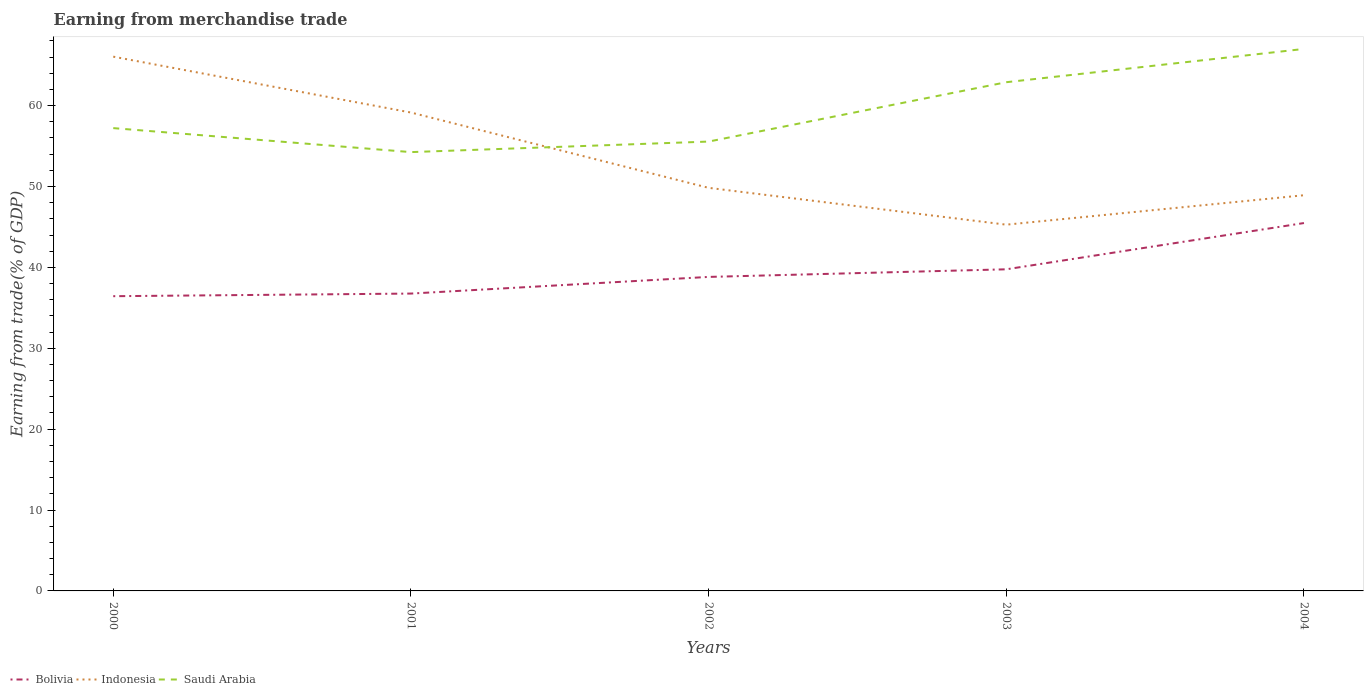How many different coloured lines are there?
Give a very brief answer. 3. Across all years, what is the maximum earnings from trade in Indonesia?
Provide a short and direct response. 45.28. In which year was the earnings from trade in Bolivia maximum?
Offer a very short reply. 2000. What is the total earnings from trade in Bolivia in the graph?
Keep it short and to the point. -0.32. What is the difference between the highest and the second highest earnings from trade in Indonesia?
Ensure brevity in your answer.  20.77. Is the earnings from trade in Bolivia strictly greater than the earnings from trade in Indonesia over the years?
Provide a succinct answer. Yes. How many lines are there?
Your response must be concise. 3. Are the values on the major ticks of Y-axis written in scientific E-notation?
Offer a terse response. No. Where does the legend appear in the graph?
Make the answer very short. Bottom left. What is the title of the graph?
Your response must be concise. Earning from merchandise trade. Does "Sub-Saharan Africa (developing only)" appear as one of the legend labels in the graph?
Keep it short and to the point. No. What is the label or title of the X-axis?
Your answer should be very brief. Years. What is the label or title of the Y-axis?
Provide a short and direct response. Earning from trade(% of GDP). What is the Earning from trade(% of GDP) in Bolivia in 2000?
Give a very brief answer. 36.44. What is the Earning from trade(% of GDP) in Indonesia in 2000?
Your answer should be compact. 66.05. What is the Earning from trade(% of GDP) of Saudi Arabia in 2000?
Provide a short and direct response. 57.22. What is the Earning from trade(% of GDP) of Bolivia in 2001?
Ensure brevity in your answer.  36.76. What is the Earning from trade(% of GDP) of Indonesia in 2001?
Your response must be concise. 59.14. What is the Earning from trade(% of GDP) of Saudi Arabia in 2001?
Give a very brief answer. 54.25. What is the Earning from trade(% of GDP) in Bolivia in 2002?
Offer a very short reply. 38.82. What is the Earning from trade(% of GDP) of Indonesia in 2002?
Your response must be concise. 49.83. What is the Earning from trade(% of GDP) of Saudi Arabia in 2002?
Ensure brevity in your answer.  55.55. What is the Earning from trade(% of GDP) of Bolivia in 2003?
Your answer should be compact. 39.76. What is the Earning from trade(% of GDP) of Indonesia in 2003?
Give a very brief answer. 45.28. What is the Earning from trade(% of GDP) of Saudi Arabia in 2003?
Offer a terse response. 62.89. What is the Earning from trade(% of GDP) of Bolivia in 2004?
Make the answer very short. 45.48. What is the Earning from trade(% of GDP) of Indonesia in 2004?
Offer a terse response. 48.92. What is the Earning from trade(% of GDP) in Saudi Arabia in 2004?
Keep it short and to the point. 67.01. Across all years, what is the maximum Earning from trade(% of GDP) of Bolivia?
Your response must be concise. 45.48. Across all years, what is the maximum Earning from trade(% of GDP) in Indonesia?
Your answer should be very brief. 66.05. Across all years, what is the maximum Earning from trade(% of GDP) in Saudi Arabia?
Provide a short and direct response. 67.01. Across all years, what is the minimum Earning from trade(% of GDP) of Bolivia?
Give a very brief answer. 36.44. Across all years, what is the minimum Earning from trade(% of GDP) in Indonesia?
Your response must be concise. 45.28. Across all years, what is the minimum Earning from trade(% of GDP) of Saudi Arabia?
Provide a short and direct response. 54.25. What is the total Earning from trade(% of GDP) of Bolivia in the graph?
Your answer should be very brief. 197.26. What is the total Earning from trade(% of GDP) in Indonesia in the graph?
Give a very brief answer. 269.23. What is the total Earning from trade(% of GDP) of Saudi Arabia in the graph?
Provide a succinct answer. 296.92. What is the difference between the Earning from trade(% of GDP) of Bolivia in 2000 and that in 2001?
Your answer should be very brief. -0.32. What is the difference between the Earning from trade(% of GDP) of Indonesia in 2000 and that in 2001?
Make the answer very short. 6.91. What is the difference between the Earning from trade(% of GDP) of Saudi Arabia in 2000 and that in 2001?
Offer a terse response. 2.97. What is the difference between the Earning from trade(% of GDP) in Bolivia in 2000 and that in 2002?
Make the answer very short. -2.38. What is the difference between the Earning from trade(% of GDP) of Indonesia in 2000 and that in 2002?
Provide a short and direct response. 16.22. What is the difference between the Earning from trade(% of GDP) in Saudi Arabia in 2000 and that in 2002?
Give a very brief answer. 1.66. What is the difference between the Earning from trade(% of GDP) in Bolivia in 2000 and that in 2003?
Your answer should be compact. -3.32. What is the difference between the Earning from trade(% of GDP) in Indonesia in 2000 and that in 2003?
Your answer should be compact. 20.77. What is the difference between the Earning from trade(% of GDP) of Saudi Arabia in 2000 and that in 2003?
Ensure brevity in your answer.  -5.68. What is the difference between the Earning from trade(% of GDP) of Bolivia in 2000 and that in 2004?
Ensure brevity in your answer.  -9.04. What is the difference between the Earning from trade(% of GDP) of Indonesia in 2000 and that in 2004?
Your answer should be very brief. 17.13. What is the difference between the Earning from trade(% of GDP) of Saudi Arabia in 2000 and that in 2004?
Make the answer very short. -9.79. What is the difference between the Earning from trade(% of GDP) of Bolivia in 2001 and that in 2002?
Your response must be concise. -2.06. What is the difference between the Earning from trade(% of GDP) of Indonesia in 2001 and that in 2002?
Offer a terse response. 9.31. What is the difference between the Earning from trade(% of GDP) in Saudi Arabia in 2001 and that in 2002?
Keep it short and to the point. -1.3. What is the difference between the Earning from trade(% of GDP) in Bolivia in 2001 and that in 2003?
Keep it short and to the point. -3. What is the difference between the Earning from trade(% of GDP) of Indonesia in 2001 and that in 2003?
Offer a terse response. 13.86. What is the difference between the Earning from trade(% of GDP) of Saudi Arabia in 2001 and that in 2003?
Make the answer very short. -8.64. What is the difference between the Earning from trade(% of GDP) in Bolivia in 2001 and that in 2004?
Give a very brief answer. -8.72. What is the difference between the Earning from trade(% of GDP) of Indonesia in 2001 and that in 2004?
Your answer should be compact. 10.22. What is the difference between the Earning from trade(% of GDP) in Saudi Arabia in 2001 and that in 2004?
Your answer should be compact. -12.75. What is the difference between the Earning from trade(% of GDP) of Bolivia in 2002 and that in 2003?
Your answer should be compact. -0.94. What is the difference between the Earning from trade(% of GDP) in Indonesia in 2002 and that in 2003?
Your response must be concise. 4.55. What is the difference between the Earning from trade(% of GDP) in Saudi Arabia in 2002 and that in 2003?
Your answer should be very brief. -7.34. What is the difference between the Earning from trade(% of GDP) in Bolivia in 2002 and that in 2004?
Provide a succinct answer. -6.66. What is the difference between the Earning from trade(% of GDP) of Indonesia in 2002 and that in 2004?
Your answer should be compact. 0.91. What is the difference between the Earning from trade(% of GDP) of Saudi Arabia in 2002 and that in 2004?
Your response must be concise. -11.45. What is the difference between the Earning from trade(% of GDP) of Bolivia in 2003 and that in 2004?
Your response must be concise. -5.72. What is the difference between the Earning from trade(% of GDP) of Indonesia in 2003 and that in 2004?
Offer a terse response. -3.64. What is the difference between the Earning from trade(% of GDP) of Saudi Arabia in 2003 and that in 2004?
Offer a very short reply. -4.11. What is the difference between the Earning from trade(% of GDP) in Bolivia in 2000 and the Earning from trade(% of GDP) in Indonesia in 2001?
Your answer should be very brief. -22.71. What is the difference between the Earning from trade(% of GDP) in Bolivia in 2000 and the Earning from trade(% of GDP) in Saudi Arabia in 2001?
Your answer should be compact. -17.81. What is the difference between the Earning from trade(% of GDP) of Indonesia in 2000 and the Earning from trade(% of GDP) of Saudi Arabia in 2001?
Provide a short and direct response. 11.8. What is the difference between the Earning from trade(% of GDP) of Bolivia in 2000 and the Earning from trade(% of GDP) of Indonesia in 2002?
Your answer should be very brief. -13.4. What is the difference between the Earning from trade(% of GDP) in Bolivia in 2000 and the Earning from trade(% of GDP) in Saudi Arabia in 2002?
Ensure brevity in your answer.  -19.12. What is the difference between the Earning from trade(% of GDP) of Indonesia in 2000 and the Earning from trade(% of GDP) of Saudi Arabia in 2002?
Give a very brief answer. 10.5. What is the difference between the Earning from trade(% of GDP) of Bolivia in 2000 and the Earning from trade(% of GDP) of Indonesia in 2003?
Give a very brief answer. -8.84. What is the difference between the Earning from trade(% of GDP) of Bolivia in 2000 and the Earning from trade(% of GDP) of Saudi Arabia in 2003?
Your response must be concise. -26.45. What is the difference between the Earning from trade(% of GDP) of Indonesia in 2000 and the Earning from trade(% of GDP) of Saudi Arabia in 2003?
Your response must be concise. 3.16. What is the difference between the Earning from trade(% of GDP) in Bolivia in 2000 and the Earning from trade(% of GDP) in Indonesia in 2004?
Ensure brevity in your answer.  -12.48. What is the difference between the Earning from trade(% of GDP) of Bolivia in 2000 and the Earning from trade(% of GDP) of Saudi Arabia in 2004?
Offer a very short reply. -30.57. What is the difference between the Earning from trade(% of GDP) of Indonesia in 2000 and the Earning from trade(% of GDP) of Saudi Arabia in 2004?
Your answer should be very brief. -0.95. What is the difference between the Earning from trade(% of GDP) in Bolivia in 2001 and the Earning from trade(% of GDP) in Indonesia in 2002?
Your answer should be compact. -13.07. What is the difference between the Earning from trade(% of GDP) in Bolivia in 2001 and the Earning from trade(% of GDP) in Saudi Arabia in 2002?
Ensure brevity in your answer.  -18.79. What is the difference between the Earning from trade(% of GDP) in Indonesia in 2001 and the Earning from trade(% of GDP) in Saudi Arabia in 2002?
Make the answer very short. 3.59. What is the difference between the Earning from trade(% of GDP) in Bolivia in 2001 and the Earning from trade(% of GDP) in Indonesia in 2003?
Provide a short and direct response. -8.52. What is the difference between the Earning from trade(% of GDP) of Bolivia in 2001 and the Earning from trade(% of GDP) of Saudi Arabia in 2003?
Provide a short and direct response. -26.13. What is the difference between the Earning from trade(% of GDP) in Indonesia in 2001 and the Earning from trade(% of GDP) in Saudi Arabia in 2003?
Provide a succinct answer. -3.75. What is the difference between the Earning from trade(% of GDP) in Bolivia in 2001 and the Earning from trade(% of GDP) in Indonesia in 2004?
Make the answer very short. -12.16. What is the difference between the Earning from trade(% of GDP) in Bolivia in 2001 and the Earning from trade(% of GDP) in Saudi Arabia in 2004?
Keep it short and to the point. -30.24. What is the difference between the Earning from trade(% of GDP) of Indonesia in 2001 and the Earning from trade(% of GDP) of Saudi Arabia in 2004?
Provide a succinct answer. -7.86. What is the difference between the Earning from trade(% of GDP) in Bolivia in 2002 and the Earning from trade(% of GDP) in Indonesia in 2003?
Offer a terse response. -6.46. What is the difference between the Earning from trade(% of GDP) of Bolivia in 2002 and the Earning from trade(% of GDP) of Saudi Arabia in 2003?
Keep it short and to the point. -24.07. What is the difference between the Earning from trade(% of GDP) of Indonesia in 2002 and the Earning from trade(% of GDP) of Saudi Arabia in 2003?
Offer a very short reply. -13.06. What is the difference between the Earning from trade(% of GDP) in Bolivia in 2002 and the Earning from trade(% of GDP) in Indonesia in 2004?
Offer a very short reply. -10.1. What is the difference between the Earning from trade(% of GDP) of Bolivia in 2002 and the Earning from trade(% of GDP) of Saudi Arabia in 2004?
Make the answer very short. -28.18. What is the difference between the Earning from trade(% of GDP) of Indonesia in 2002 and the Earning from trade(% of GDP) of Saudi Arabia in 2004?
Offer a terse response. -17.17. What is the difference between the Earning from trade(% of GDP) in Bolivia in 2003 and the Earning from trade(% of GDP) in Indonesia in 2004?
Your response must be concise. -9.16. What is the difference between the Earning from trade(% of GDP) of Bolivia in 2003 and the Earning from trade(% of GDP) of Saudi Arabia in 2004?
Your answer should be very brief. -27.24. What is the difference between the Earning from trade(% of GDP) of Indonesia in 2003 and the Earning from trade(% of GDP) of Saudi Arabia in 2004?
Make the answer very short. -21.73. What is the average Earning from trade(% of GDP) in Bolivia per year?
Offer a terse response. 39.45. What is the average Earning from trade(% of GDP) in Indonesia per year?
Your response must be concise. 53.85. What is the average Earning from trade(% of GDP) in Saudi Arabia per year?
Ensure brevity in your answer.  59.38. In the year 2000, what is the difference between the Earning from trade(% of GDP) of Bolivia and Earning from trade(% of GDP) of Indonesia?
Give a very brief answer. -29.61. In the year 2000, what is the difference between the Earning from trade(% of GDP) of Bolivia and Earning from trade(% of GDP) of Saudi Arabia?
Offer a very short reply. -20.78. In the year 2000, what is the difference between the Earning from trade(% of GDP) of Indonesia and Earning from trade(% of GDP) of Saudi Arabia?
Offer a very short reply. 8.83. In the year 2001, what is the difference between the Earning from trade(% of GDP) in Bolivia and Earning from trade(% of GDP) in Indonesia?
Your answer should be very brief. -22.38. In the year 2001, what is the difference between the Earning from trade(% of GDP) of Bolivia and Earning from trade(% of GDP) of Saudi Arabia?
Provide a short and direct response. -17.49. In the year 2001, what is the difference between the Earning from trade(% of GDP) of Indonesia and Earning from trade(% of GDP) of Saudi Arabia?
Your response must be concise. 4.89. In the year 2002, what is the difference between the Earning from trade(% of GDP) in Bolivia and Earning from trade(% of GDP) in Indonesia?
Provide a succinct answer. -11.01. In the year 2002, what is the difference between the Earning from trade(% of GDP) of Bolivia and Earning from trade(% of GDP) of Saudi Arabia?
Offer a very short reply. -16.73. In the year 2002, what is the difference between the Earning from trade(% of GDP) of Indonesia and Earning from trade(% of GDP) of Saudi Arabia?
Keep it short and to the point. -5.72. In the year 2003, what is the difference between the Earning from trade(% of GDP) of Bolivia and Earning from trade(% of GDP) of Indonesia?
Provide a short and direct response. -5.52. In the year 2003, what is the difference between the Earning from trade(% of GDP) in Bolivia and Earning from trade(% of GDP) in Saudi Arabia?
Make the answer very short. -23.13. In the year 2003, what is the difference between the Earning from trade(% of GDP) in Indonesia and Earning from trade(% of GDP) in Saudi Arabia?
Ensure brevity in your answer.  -17.61. In the year 2004, what is the difference between the Earning from trade(% of GDP) in Bolivia and Earning from trade(% of GDP) in Indonesia?
Give a very brief answer. -3.44. In the year 2004, what is the difference between the Earning from trade(% of GDP) of Bolivia and Earning from trade(% of GDP) of Saudi Arabia?
Provide a succinct answer. -21.52. In the year 2004, what is the difference between the Earning from trade(% of GDP) in Indonesia and Earning from trade(% of GDP) in Saudi Arabia?
Give a very brief answer. -18.09. What is the ratio of the Earning from trade(% of GDP) of Indonesia in 2000 to that in 2001?
Offer a very short reply. 1.12. What is the ratio of the Earning from trade(% of GDP) of Saudi Arabia in 2000 to that in 2001?
Give a very brief answer. 1.05. What is the ratio of the Earning from trade(% of GDP) of Bolivia in 2000 to that in 2002?
Make the answer very short. 0.94. What is the ratio of the Earning from trade(% of GDP) of Indonesia in 2000 to that in 2002?
Your response must be concise. 1.33. What is the ratio of the Earning from trade(% of GDP) in Saudi Arabia in 2000 to that in 2002?
Give a very brief answer. 1.03. What is the ratio of the Earning from trade(% of GDP) of Bolivia in 2000 to that in 2003?
Ensure brevity in your answer.  0.92. What is the ratio of the Earning from trade(% of GDP) in Indonesia in 2000 to that in 2003?
Your answer should be compact. 1.46. What is the ratio of the Earning from trade(% of GDP) of Saudi Arabia in 2000 to that in 2003?
Your response must be concise. 0.91. What is the ratio of the Earning from trade(% of GDP) in Bolivia in 2000 to that in 2004?
Provide a succinct answer. 0.8. What is the ratio of the Earning from trade(% of GDP) in Indonesia in 2000 to that in 2004?
Offer a terse response. 1.35. What is the ratio of the Earning from trade(% of GDP) in Saudi Arabia in 2000 to that in 2004?
Give a very brief answer. 0.85. What is the ratio of the Earning from trade(% of GDP) in Bolivia in 2001 to that in 2002?
Keep it short and to the point. 0.95. What is the ratio of the Earning from trade(% of GDP) of Indonesia in 2001 to that in 2002?
Your answer should be very brief. 1.19. What is the ratio of the Earning from trade(% of GDP) of Saudi Arabia in 2001 to that in 2002?
Offer a terse response. 0.98. What is the ratio of the Earning from trade(% of GDP) in Bolivia in 2001 to that in 2003?
Offer a very short reply. 0.92. What is the ratio of the Earning from trade(% of GDP) of Indonesia in 2001 to that in 2003?
Provide a short and direct response. 1.31. What is the ratio of the Earning from trade(% of GDP) of Saudi Arabia in 2001 to that in 2003?
Make the answer very short. 0.86. What is the ratio of the Earning from trade(% of GDP) in Bolivia in 2001 to that in 2004?
Your response must be concise. 0.81. What is the ratio of the Earning from trade(% of GDP) in Indonesia in 2001 to that in 2004?
Your response must be concise. 1.21. What is the ratio of the Earning from trade(% of GDP) in Saudi Arabia in 2001 to that in 2004?
Give a very brief answer. 0.81. What is the ratio of the Earning from trade(% of GDP) in Bolivia in 2002 to that in 2003?
Offer a terse response. 0.98. What is the ratio of the Earning from trade(% of GDP) in Indonesia in 2002 to that in 2003?
Provide a succinct answer. 1.1. What is the ratio of the Earning from trade(% of GDP) in Saudi Arabia in 2002 to that in 2003?
Offer a terse response. 0.88. What is the ratio of the Earning from trade(% of GDP) in Bolivia in 2002 to that in 2004?
Your answer should be very brief. 0.85. What is the ratio of the Earning from trade(% of GDP) in Indonesia in 2002 to that in 2004?
Your response must be concise. 1.02. What is the ratio of the Earning from trade(% of GDP) in Saudi Arabia in 2002 to that in 2004?
Your response must be concise. 0.83. What is the ratio of the Earning from trade(% of GDP) in Bolivia in 2003 to that in 2004?
Ensure brevity in your answer.  0.87. What is the ratio of the Earning from trade(% of GDP) of Indonesia in 2003 to that in 2004?
Ensure brevity in your answer.  0.93. What is the ratio of the Earning from trade(% of GDP) in Saudi Arabia in 2003 to that in 2004?
Your answer should be very brief. 0.94. What is the difference between the highest and the second highest Earning from trade(% of GDP) in Bolivia?
Make the answer very short. 5.72. What is the difference between the highest and the second highest Earning from trade(% of GDP) of Indonesia?
Your answer should be very brief. 6.91. What is the difference between the highest and the second highest Earning from trade(% of GDP) in Saudi Arabia?
Offer a terse response. 4.11. What is the difference between the highest and the lowest Earning from trade(% of GDP) of Bolivia?
Offer a very short reply. 9.04. What is the difference between the highest and the lowest Earning from trade(% of GDP) of Indonesia?
Ensure brevity in your answer.  20.77. What is the difference between the highest and the lowest Earning from trade(% of GDP) in Saudi Arabia?
Provide a short and direct response. 12.75. 